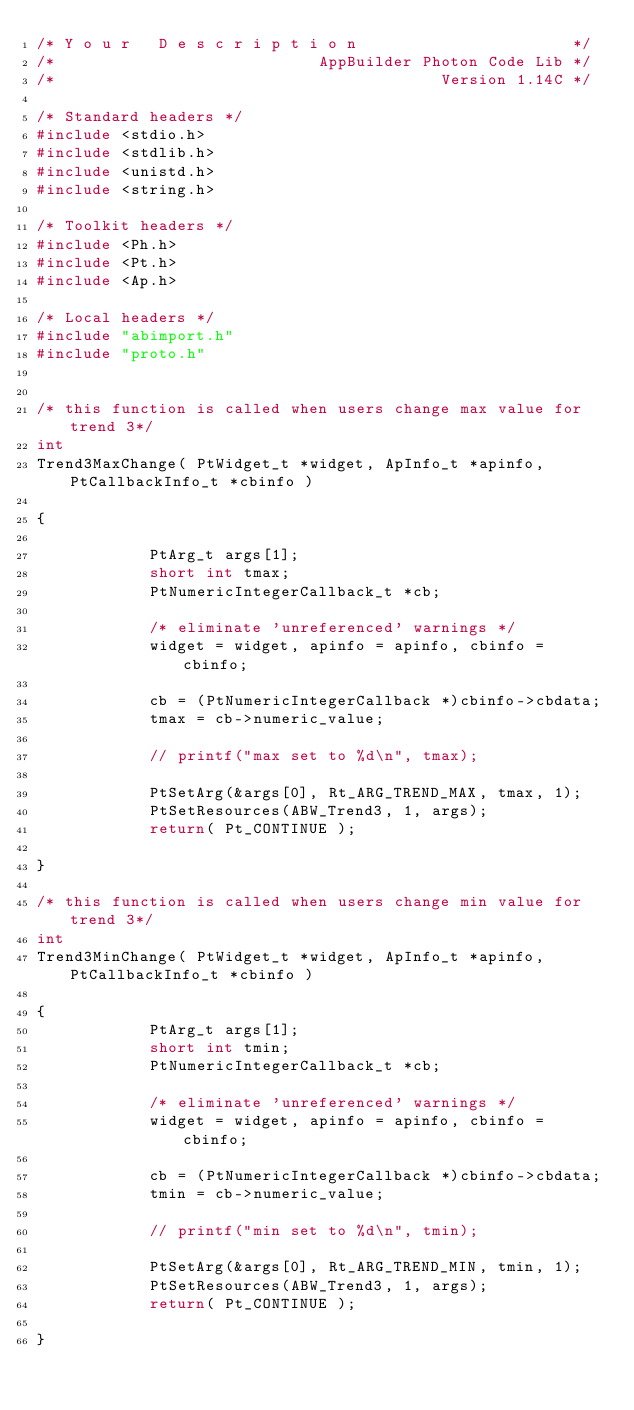Convert code to text. <code><loc_0><loc_0><loc_500><loc_500><_C++_>/* Y o u r   D e s c r i p t i o n                       */
/*                            AppBuilder Photon Code Lib */
/*                                         Version 1.14C */

/* Standard headers */
#include <stdio.h>
#include <stdlib.h>
#include <unistd.h>
#include <string.h>

/* Toolkit headers */
#include <Ph.h>
#include <Pt.h>
#include <Ap.h>

/* Local headers */
#include "abimport.h"
#include "proto.h"


/* this function is called when users change max value for trend 3*/
int
Trend3MaxChange( PtWidget_t *widget, ApInfo_t *apinfo, PtCallbackInfo_t *cbinfo )

{
  
            PtArg_t args[1];
            short int tmax;
            PtNumericIntegerCallback_t *cb;
  
            /* eliminate 'unreferenced' warnings */
            widget = widget, apinfo = apinfo, cbinfo = cbinfo;
  
            cb = (PtNumericIntegerCallback *)cbinfo->cbdata;
            tmax = cb->numeric_value;
  
            // printf("max set to %d\n", tmax);
  
            PtSetArg(&args[0], Rt_ARG_TREND_MAX, tmax, 1);
            PtSetResources(ABW_Trend3, 1, args);
            return( Pt_CONTINUE );
  
}

/* this function is called when users change min value for trend 3*/
int
Trend3MinChange( PtWidget_t *widget, ApInfo_t *apinfo, PtCallbackInfo_t *cbinfo )

{
            PtArg_t args[1];
            short int tmin;
            PtNumericIntegerCallback_t *cb;
  
            /* eliminate 'unreferenced' warnings */
            widget = widget, apinfo = apinfo, cbinfo = cbinfo;
  
            cb = (PtNumericIntegerCallback *)cbinfo->cbdata;
            tmin = cb->numeric_value;
  
            // printf("min set to %d\n", tmin);
  
            PtSetArg(&args[0], Rt_ARG_TREND_MIN, tmin, 1);
            PtSetResources(ABW_Trend3, 1, args);
            return( Pt_CONTINUE );
  
}
</code> 